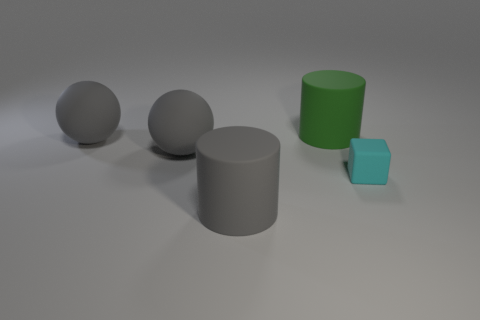Subtract all gray cylinders. How many cylinders are left? 1 Add 3 blocks. How many objects exist? 8 Subtract all spheres. How many objects are left? 3 Subtract all gray cylinders. Subtract all purple spheres. How many cylinders are left? 1 Subtract all cyan spheres. How many gray cylinders are left? 1 Subtract all green rubber objects. Subtract all cyan cubes. How many objects are left? 3 Add 5 cylinders. How many cylinders are left? 7 Add 3 tiny cyan things. How many tiny cyan things exist? 4 Subtract 1 cyan blocks. How many objects are left? 4 